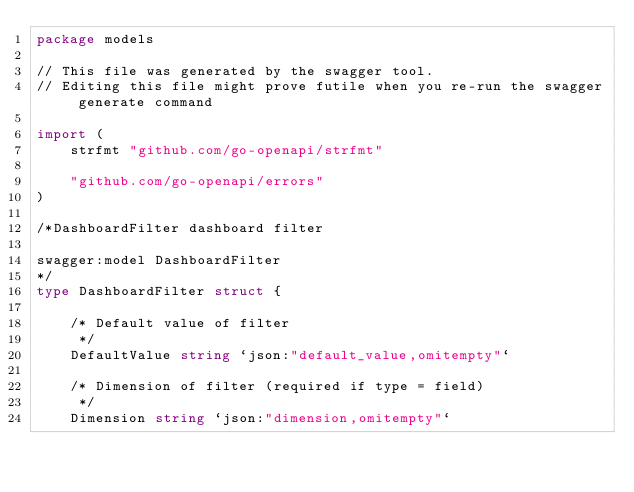Convert code to text. <code><loc_0><loc_0><loc_500><loc_500><_Go_>package models

// This file was generated by the swagger tool.
// Editing this file might prove futile when you re-run the swagger generate command

import (
	strfmt "github.com/go-openapi/strfmt"

	"github.com/go-openapi/errors"
)

/*DashboardFilter dashboard filter

swagger:model DashboardFilter
*/
type DashboardFilter struct {

	/* Default value of filter
	 */
	DefaultValue string `json:"default_value,omitempty"`

	/* Dimension of filter (required if type = field)
	 */
	Dimension string `json:"dimension,omitempty"`
</code> 